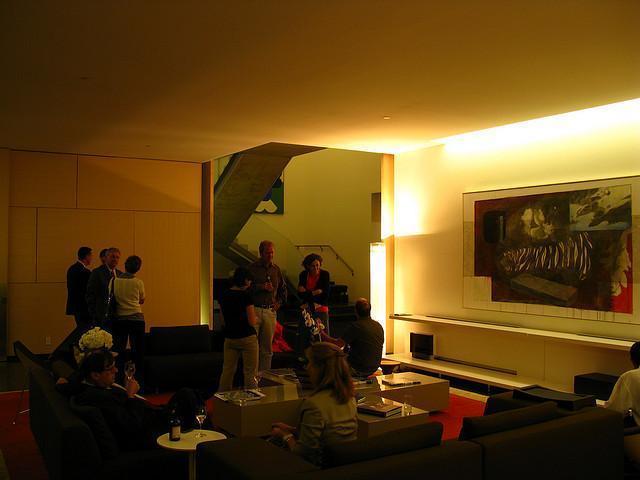How many couches are in the photo?
Give a very brief answer. 3. How many people are there?
Give a very brief answer. 6. How many clocks do you see?
Give a very brief answer. 0. 